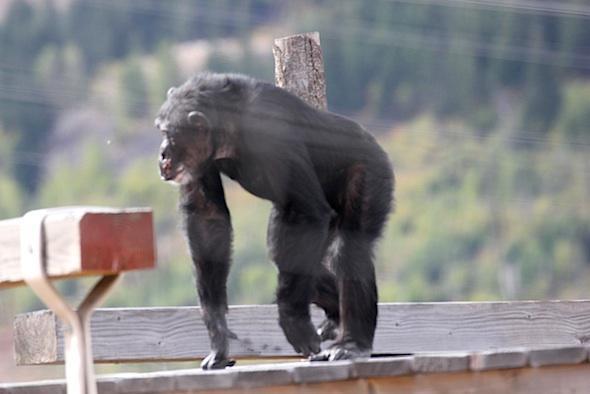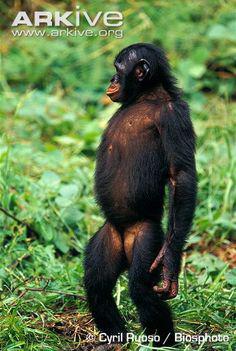The first image is the image on the left, the second image is the image on the right. Considering the images on both sides, is "One chimp is standing on four feet." valid? Answer yes or no. Yes. The first image is the image on the left, the second image is the image on the right. Assess this claim about the two images: "In one of the images a monkey is on all four legs.". Correct or not? Answer yes or no. Yes. 